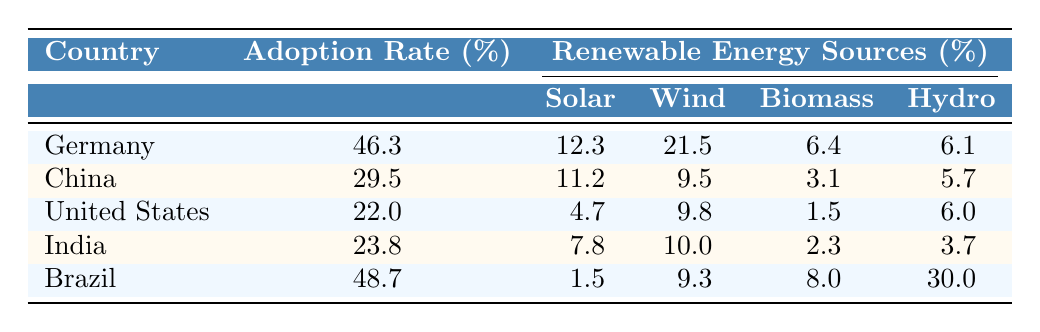What is the adoption rate of Germany? The table lists Germany's adoption rate directly, which is 46.3%.
Answer: 46.3 What is the percentage of wind energy in India's renewable energy sources? The table specifies that wind energy contributes 10.0% to India's renewable energy sources.
Answer: 10.0 Which country has the lowest adoption rate? Upon reviewing the adoption rates, the United States has the lowest rate at 22.0%.
Answer: United States What is the total percentage of renewable energy sources in Brazil? The table shows Brazil's renewable energy sources as solar (1.5%), wind (9.3%), biomass (8.0%), and hydro (30.0%). Summing these gives 1.5 + 9.3 + 8.0 + 30.0 = 48.8%.
Answer: 48.8 Is it true that Germany has a higher adoption rate than China? Comparing the adoption rates, Germany (46.3%) is indeed higher than China's (29.5%).
Answer: Yes What is the difference in adoption rates between Brazil and India? Brazil's adoption rate is 48.7% and India's is 23.8%. The difference is calculated as 48.7 - 23.8 = 24.9%.
Answer: 24.9 Which country generates more solar energy, Germany or China? Germany produces 12.3% solar energy, while China produces 11.2%. Thus, Germany generates more solar energy.
Answer: Germany What is the average adoption rate among the five countries listed? To find the average adoption rate, sum the rates (46.3 + 29.5 + 22.0 + 23.8 + 48.7 = 170.3) and divide by the number of countries (5), giving 170.3 / 5 = 34.06%.
Answer: 34.06 Which renewable energy source has the highest percentage in Brazil? The table reveals that hydro energy is the highest in Brazil, at 30.0%.
Answer: Hydro How does the biomass energy percentage in the United States compare to that in China? The table shows biomass in the United States as 1.5% and in China as 3.1%. Therefore, China's biomass percentage is higher.
Answer: China 